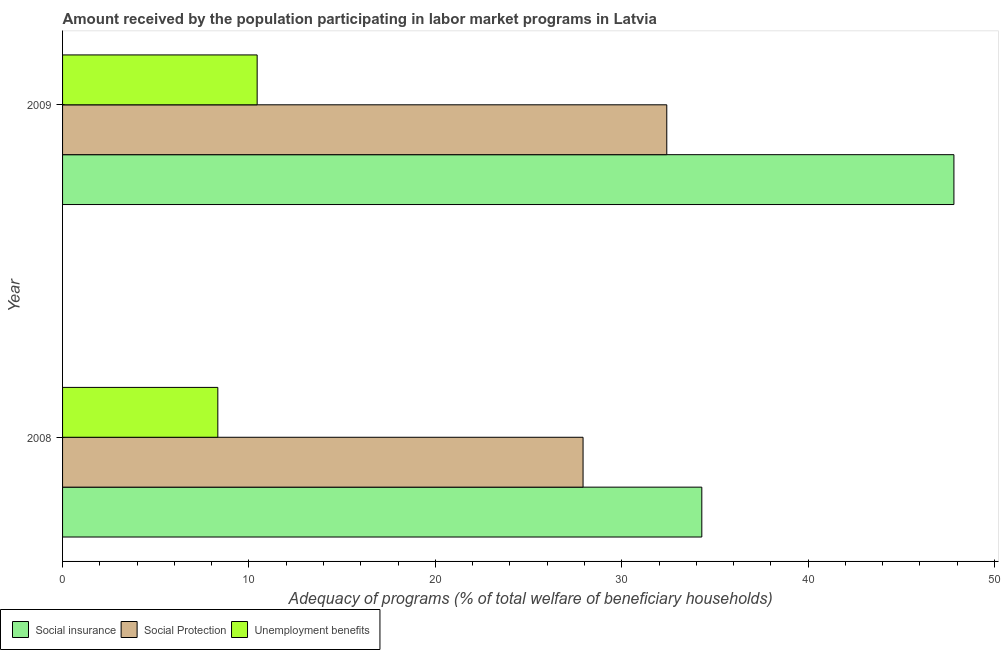Are the number of bars per tick equal to the number of legend labels?
Provide a succinct answer. Yes. How many bars are there on the 2nd tick from the top?
Provide a succinct answer. 3. What is the amount received by the population participating in unemployment benefits programs in 2008?
Keep it short and to the point. 8.33. Across all years, what is the maximum amount received by the population participating in unemployment benefits programs?
Keep it short and to the point. 10.44. Across all years, what is the minimum amount received by the population participating in social insurance programs?
Offer a terse response. 34.3. What is the total amount received by the population participating in unemployment benefits programs in the graph?
Provide a succinct answer. 18.77. What is the difference between the amount received by the population participating in social protection programs in 2008 and that in 2009?
Make the answer very short. -4.49. What is the difference between the amount received by the population participating in social protection programs in 2009 and the amount received by the population participating in social insurance programs in 2008?
Give a very brief answer. -1.88. What is the average amount received by the population participating in social insurance programs per year?
Ensure brevity in your answer.  41.06. In the year 2009, what is the difference between the amount received by the population participating in social protection programs and amount received by the population participating in social insurance programs?
Your answer should be compact. -15.4. What is the ratio of the amount received by the population participating in social insurance programs in 2008 to that in 2009?
Ensure brevity in your answer.  0.72. What does the 2nd bar from the top in 2008 represents?
Your answer should be compact. Social Protection. What does the 3rd bar from the bottom in 2009 represents?
Provide a succinct answer. Unemployment benefits. How many bars are there?
Ensure brevity in your answer.  6. Are all the bars in the graph horizontal?
Offer a very short reply. Yes. Does the graph contain grids?
Keep it short and to the point. No. How are the legend labels stacked?
Your answer should be compact. Horizontal. What is the title of the graph?
Keep it short and to the point. Amount received by the population participating in labor market programs in Latvia. Does "Primary" appear as one of the legend labels in the graph?
Make the answer very short. No. What is the label or title of the X-axis?
Give a very brief answer. Adequacy of programs (% of total welfare of beneficiary households). What is the label or title of the Y-axis?
Provide a short and direct response. Year. What is the Adequacy of programs (% of total welfare of beneficiary households) in Social insurance in 2008?
Make the answer very short. 34.3. What is the Adequacy of programs (% of total welfare of beneficiary households) of Social Protection in 2008?
Give a very brief answer. 27.93. What is the Adequacy of programs (% of total welfare of beneficiary households) in Unemployment benefits in 2008?
Provide a short and direct response. 8.33. What is the Adequacy of programs (% of total welfare of beneficiary households) in Social insurance in 2009?
Keep it short and to the point. 47.82. What is the Adequacy of programs (% of total welfare of beneficiary households) of Social Protection in 2009?
Make the answer very short. 32.42. What is the Adequacy of programs (% of total welfare of beneficiary households) of Unemployment benefits in 2009?
Provide a succinct answer. 10.44. Across all years, what is the maximum Adequacy of programs (% of total welfare of beneficiary households) in Social insurance?
Make the answer very short. 47.82. Across all years, what is the maximum Adequacy of programs (% of total welfare of beneficiary households) in Social Protection?
Offer a very short reply. 32.42. Across all years, what is the maximum Adequacy of programs (% of total welfare of beneficiary households) of Unemployment benefits?
Your answer should be compact. 10.44. Across all years, what is the minimum Adequacy of programs (% of total welfare of beneficiary households) of Social insurance?
Provide a short and direct response. 34.3. Across all years, what is the minimum Adequacy of programs (% of total welfare of beneficiary households) in Social Protection?
Provide a short and direct response. 27.93. Across all years, what is the minimum Adequacy of programs (% of total welfare of beneficiary households) in Unemployment benefits?
Offer a very short reply. 8.33. What is the total Adequacy of programs (% of total welfare of beneficiary households) in Social insurance in the graph?
Keep it short and to the point. 82.12. What is the total Adequacy of programs (% of total welfare of beneficiary households) in Social Protection in the graph?
Ensure brevity in your answer.  60.34. What is the total Adequacy of programs (% of total welfare of beneficiary households) in Unemployment benefits in the graph?
Offer a very short reply. 18.77. What is the difference between the Adequacy of programs (% of total welfare of beneficiary households) in Social insurance in 2008 and that in 2009?
Give a very brief answer. -13.53. What is the difference between the Adequacy of programs (% of total welfare of beneficiary households) in Social Protection in 2008 and that in 2009?
Give a very brief answer. -4.49. What is the difference between the Adequacy of programs (% of total welfare of beneficiary households) in Unemployment benefits in 2008 and that in 2009?
Your response must be concise. -2.11. What is the difference between the Adequacy of programs (% of total welfare of beneficiary households) in Social insurance in 2008 and the Adequacy of programs (% of total welfare of beneficiary households) in Social Protection in 2009?
Offer a very short reply. 1.88. What is the difference between the Adequacy of programs (% of total welfare of beneficiary households) in Social insurance in 2008 and the Adequacy of programs (% of total welfare of beneficiary households) in Unemployment benefits in 2009?
Your answer should be compact. 23.86. What is the difference between the Adequacy of programs (% of total welfare of beneficiary households) of Social Protection in 2008 and the Adequacy of programs (% of total welfare of beneficiary households) of Unemployment benefits in 2009?
Provide a succinct answer. 17.48. What is the average Adequacy of programs (% of total welfare of beneficiary households) in Social insurance per year?
Provide a succinct answer. 41.06. What is the average Adequacy of programs (% of total welfare of beneficiary households) of Social Protection per year?
Offer a very short reply. 30.17. What is the average Adequacy of programs (% of total welfare of beneficiary households) in Unemployment benefits per year?
Provide a short and direct response. 9.39. In the year 2008, what is the difference between the Adequacy of programs (% of total welfare of beneficiary households) in Social insurance and Adequacy of programs (% of total welfare of beneficiary households) in Social Protection?
Offer a very short reply. 6.37. In the year 2008, what is the difference between the Adequacy of programs (% of total welfare of beneficiary households) of Social insurance and Adequacy of programs (% of total welfare of beneficiary households) of Unemployment benefits?
Offer a very short reply. 25.97. In the year 2008, what is the difference between the Adequacy of programs (% of total welfare of beneficiary households) in Social Protection and Adequacy of programs (% of total welfare of beneficiary households) in Unemployment benefits?
Offer a very short reply. 19.59. In the year 2009, what is the difference between the Adequacy of programs (% of total welfare of beneficiary households) of Social insurance and Adequacy of programs (% of total welfare of beneficiary households) of Social Protection?
Give a very brief answer. 15.41. In the year 2009, what is the difference between the Adequacy of programs (% of total welfare of beneficiary households) in Social insurance and Adequacy of programs (% of total welfare of beneficiary households) in Unemployment benefits?
Provide a succinct answer. 37.38. In the year 2009, what is the difference between the Adequacy of programs (% of total welfare of beneficiary households) of Social Protection and Adequacy of programs (% of total welfare of beneficiary households) of Unemployment benefits?
Ensure brevity in your answer.  21.98. What is the ratio of the Adequacy of programs (% of total welfare of beneficiary households) in Social insurance in 2008 to that in 2009?
Ensure brevity in your answer.  0.72. What is the ratio of the Adequacy of programs (% of total welfare of beneficiary households) of Social Protection in 2008 to that in 2009?
Your response must be concise. 0.86. What is the ratio of the Adequacy of programs (% of total welfare of beneficiary households) of Unemployment benefits in 2008 to that in 2009?
Your response must be concise. 0.8. What is the difference between the highest and the second highest Adequacy of programs (% of total welfare of beneficiary households) of Social insurance?
Offer a terse response. 13.53. What is the difference between the highest and the second highest Adequacy of programs (% of total welfare of beneficiary households) in Social Protection?
Your response must be concise. 4.49. What is the difference between the highest and the second highest Adequacy of programs (% of total welfare of beneficiary households) of Unemployment benefits?
Your response must be concise. 2.11. What is the difference between the highest and the lowest Adequacy of programs (% of total welfare of beneficiary households) in Social insurance?
Your answer should be very brief. 13.53. What is the difference between the highest and the lowest Adequacy of programs (% of total welfare of beneficiary households) of Social Protection?
Your answer should be very brief. 4.49. What is the difference between the highest and the lowest Adequacy of programs (% of total welfare of beneficiary households) in Unemployment benefits?
Your answer should be very brief. 2.11. 